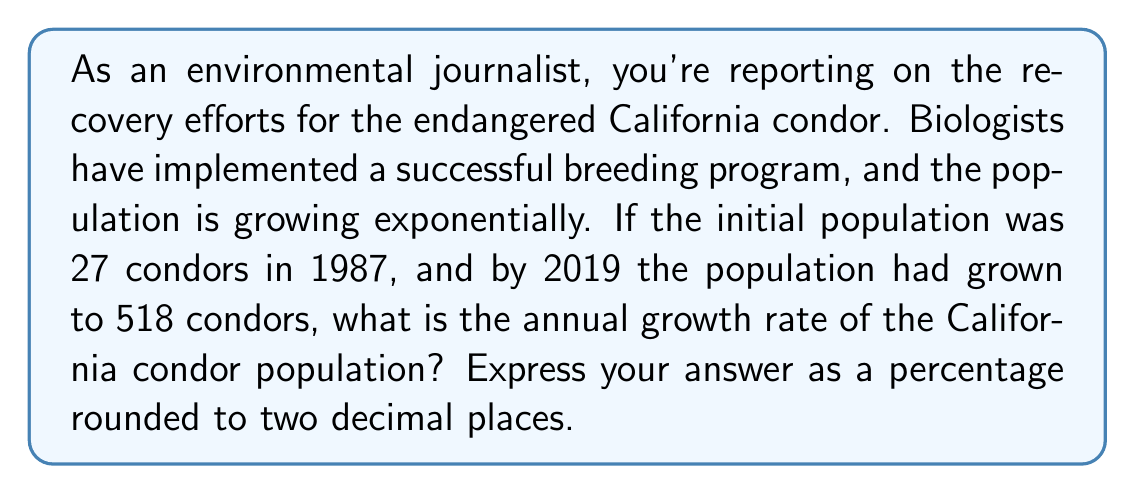Give your solution to this math problem. To solve this problem, we'll use the exponential growth formula:

$$A = P(1 + r)^t$$

Where:
$A$ = Final amount (518 condors)
$P$ = Initial amount (27 condors)
$r$ = Annual growth rate (what we're solving for)
$t$ = Time period (2019 - 1987 = 32 years)

Let's plug in the known values:

$$518 = 27(1 + r)^{32}$$

Now, we'll solve for $r$:

1) Divide both sides by 27:
   $$\frac{518}{27} = (1 + r)^{32}$$

2) Take the 32nd root of both sides:
   $$\sqrt[32]{\frac{518}{27}} = 1 + r$$

3) Subtract 1 from both sides:
   $$\sqrt[32]{\frac{518}{27}} - 1 = r$$

4) Calculate the value:
   $$r \approx 0.0995$$

5) Convert to a percentage:
   $$r \approx 9.95\%$$

Rounding to two decimal places, we get 9.95%.

This means the California condor population has been growing at an annual rate of approximately 9.95% since 1987.
Answer: 9.95% 